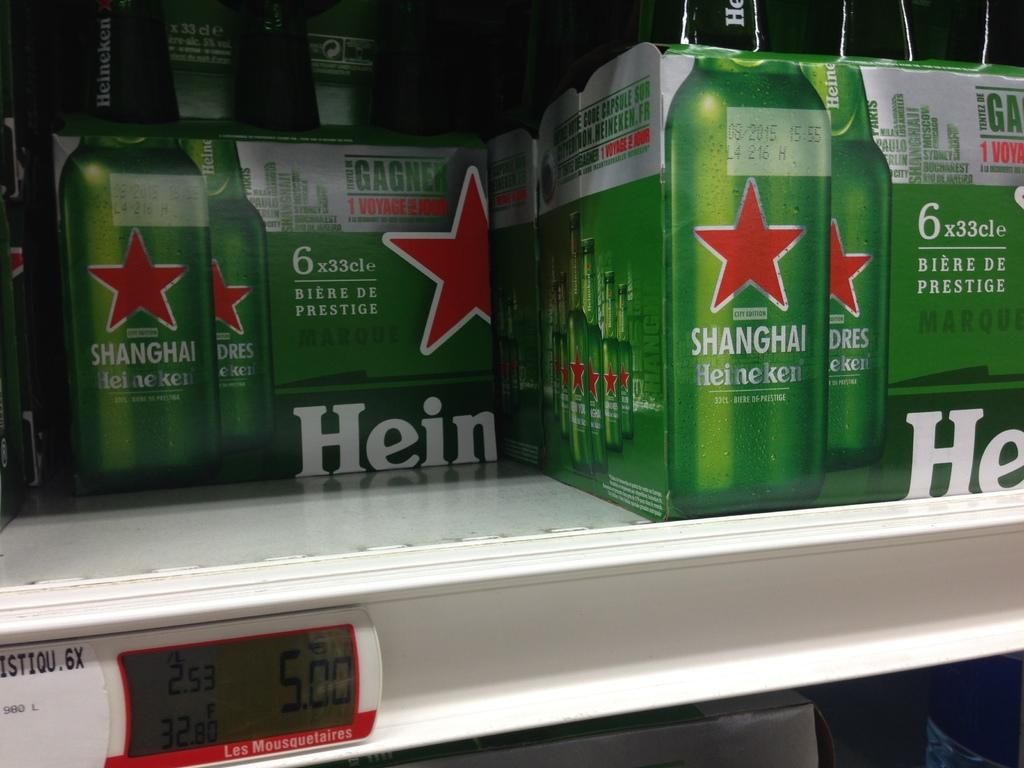<image>
Offer a succinct explanation of the picture presented. Two cases of Shanghai Heineken are on a store shelf.. 